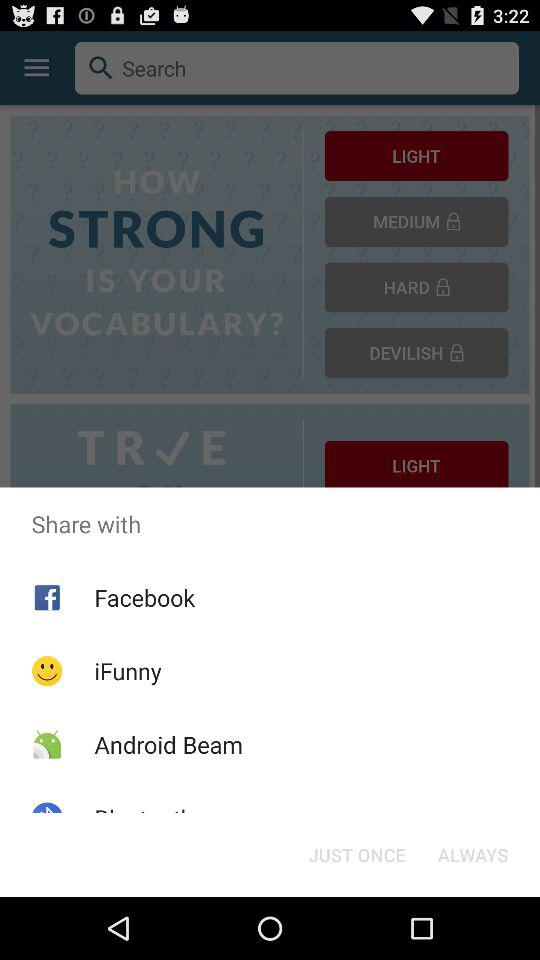Through which applications can we share? You can share through "Facebook", "iFunny" and "Android Beam". 